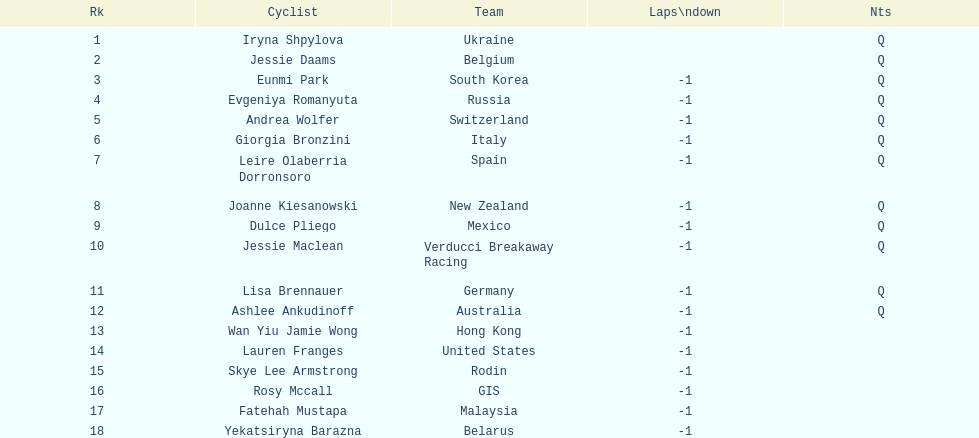Who was the rival that completed ahead of jessie maclean? Dulce Pliego. Would you be able to parse every entry in this table? {'header': ['Rk', 'Cyclist', 'Team', 'Laps\\ndown', 'Nts'], 'rows': [['1', 'Iryna Shpylova', 'Ukraine', '', 'Q'], ['2', 'Jessie Daams', 'Belgium', '', 'Q'], ['3', 'Eunmi Park', 'South Korea', '-1', 'Q'], ['4', 'Evgeniya Romanyuta', 'Russia', '-1', 'Q'], ['5', 'Andrea Wolfer', 'Switzerland', '-1', 'Q'], ['6', 'Giorgia Bronzini', 'Italy', '-1', 'Q'], ['7', 'Leire Olaberria Dorronsoro', 'Spain', '-1', 'Q'], ['8', 'Joanne Kiesanowski', 'New Zealand', '-1', 'Q'], ['9', 'Dulce Pliego', 'Mexico', '-1', 'Q'], ['10', 'Jessie Maclean', 'Verducci Breakaway Racing', '-1', 'Q'], ['11', 'Lisa Brennauer', 'Germany', '-1', 'Q'], ['12', 'Ashlee Ankudinoff', 'Australia', '-1', 'Q'], ['13', 'Wan Yiu Jamie Wong', 'Hong Kong', '-1', ''], ['14', 'Lauren Franges', 'United States', '-1', ''], ['15', 'Skye Lee Armstrong', 'Rodin', '-1', ''], ['16', 'Rosy Mccall', 'GIS', '-1', ''], ['17', 'Fatehah Mustapa', 'Malaysia', '-1', ''], ['18', 'Yekatsiryna Barazna', 'Belarus', '-1', '']]} 